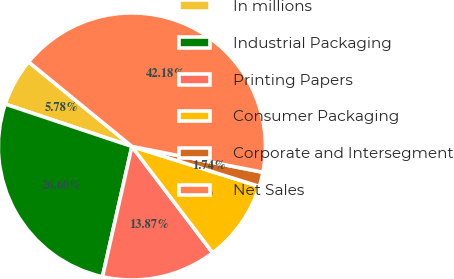Convert chart. <chart><loc_0><loc_0><loc_500><loc_500><pie_chart><fcel>In millions<fcel>Industrial Packaging<fcel>Printing Papers<fcel>Consumer Packaging<fcel>Corporate and Intersegment<fcel>Net Sales<nl><fcel>5.78%<fcel>26.6%<fcel>13.87%<fcel>9.83%<fcel>1.74%<fcel>42.18%<nl></chart> 